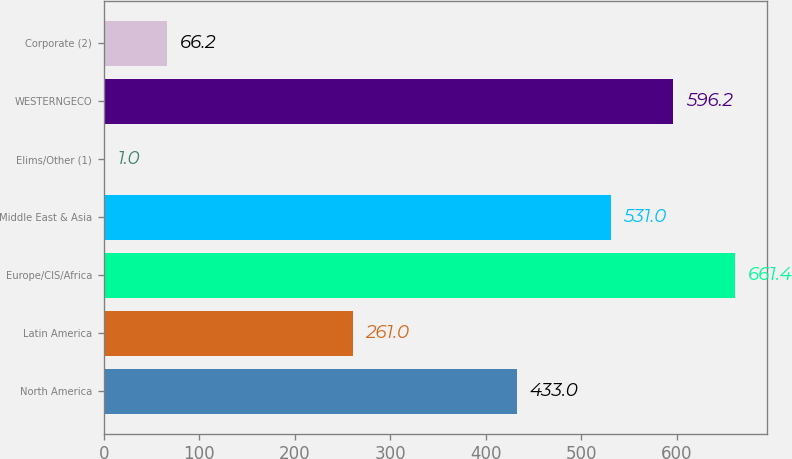Convert chart. <chart><loc_0><loc_0><loc_500><loc_500><bar_chart><fcel>North America<fcel>Latin America<fcel>Europe/CIS/Africa<fcel>Middle East & Asia<fcel>Elims/Other (1)<fcel>WESTERNGECO<fcel>Corporate (2)<nl><fcel>433<fcel>261<fcel>661.4<fcel>531<fcel>1<fcel>596.2<fcel>66.2<nl></chart> 